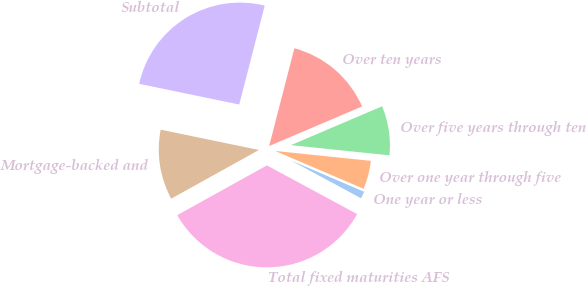Convert chart to OTSL. <chart><loc_0><loc_0><loc_500><loc_500><pie_chart><fcel>One year or less<fcel>Over one year through five<fcel>Over five years through ten<fcel>Over ten years<fcel>Subtotal<fcel>Mortgage-backed and<fcel>Total fixed maturities AFS<nl><fcel>1.44%<fcel>4.79%<fcel>8.05%<fcel>14.57%<fcel>25.77%<fcel>11.31%<fcel>34.06%<nl></chart> 